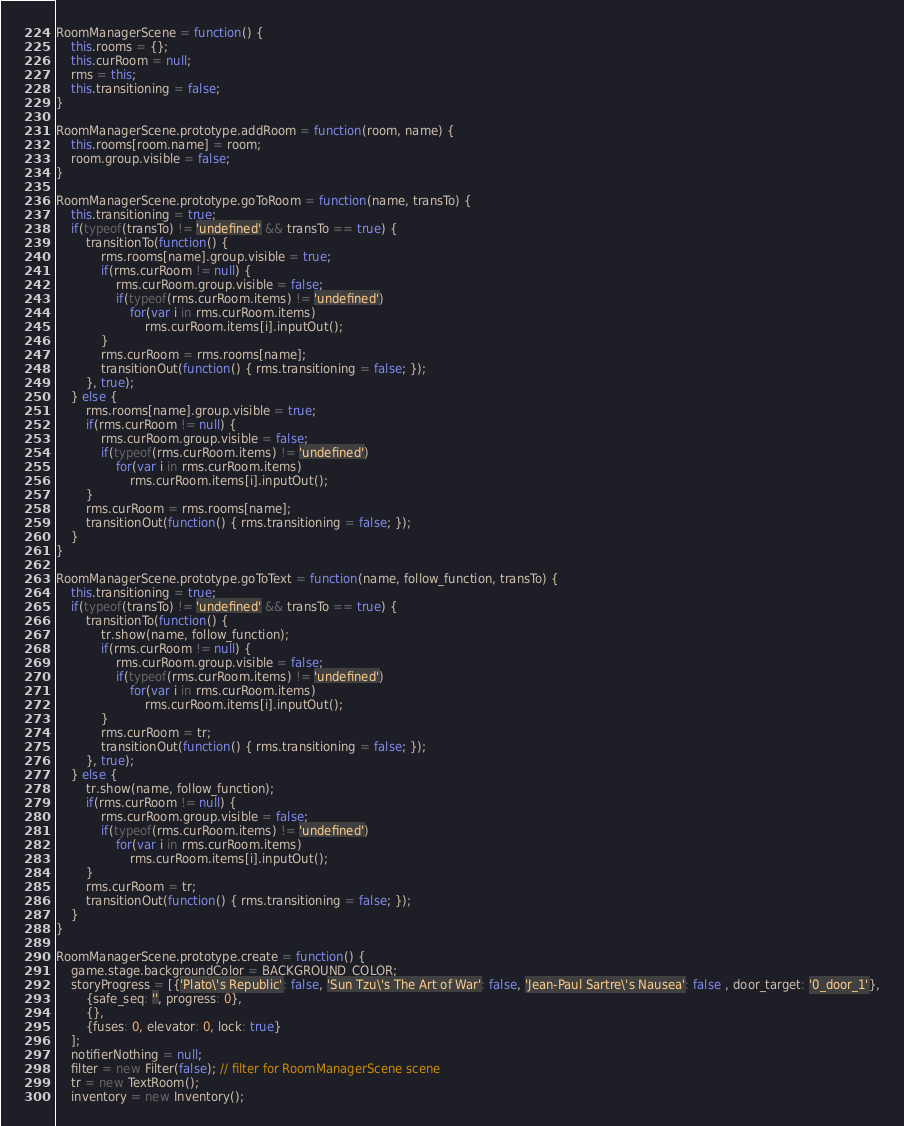<code> <loc_0><loc_0><loc_500><loc_500><_JavaScript_>RoomManagerScene = function() {
	this.rooms = {};
	this.curRoom = null;
	rms = this;
	this.transitioning = false;
}

RoomManagerScene.prototype.addRoom = function(room, name) {
	this.rooms[room.name] = room;
	room.group.visible = false;
}

RoomManagerScene.prototype.goToRoom = function(name, transTo) {
	this.transitioning = true;
	if(typeof(transTo) != 'undefined' && transTo == true) {
		transitionTo(function() {
			rms.rooms[name].group.visible = true;
			if(rms.curRoom != null) {
				rms.curRoom.group.visible = false;
				if(typeof(rms.curRoom.items) != 'undefined')
					for(var i in rms.curRoom.items)
						rms.curRoom.items[i].inputOut();
			}
			rms.curRoom = rms.rooms[name];
			transitionOut(function() { rms.transitioning = false; });
		}, true);
	} else {
		rms.rooms[name].group.visible = true;
		if(rms.curRoom != null) {
			rms.curRoom.group.visible = false;
			if(typeof(rms.curRoom.items) != 'undefined')
				for(var i in rms.curRoom.items)
					rms.curRoom.items[i].inputOut();
		}
		rms.curRoom = rms.rooms[name];
		transitionOut(function() { rms.transitioning = false; });
	}
}

RoomManagerScene.prototype.goToText = function(name, follow_function, transTo) {
	this.transitioning = true;
	if(typeof(transTo) != 'undefined' && transTo == true) {
		transitionTo(function() {
			tr.show(name, follow_function);
			if(rms.curRoom != null) {
				rms.curRoom.group.visible = false;
				if(typeof(rms.curRoom.items) != 'undefined')
					for(var i in rms.curRoom.items)
						rms.curRoom.items[i].inputOut();
			}
			rms.curRoom = tr;
			transitionOut(function() { rms.transitioning = false; });
		}, true);
	} else {
		tr.show(name, follow_function);
		if(rms.curRoom != null) {
			rms.curRoom.group.visible = false;
			if(typeof(rms.curRoom.items) != 'undefined')
				for(var i in rms.curRoom.items)
					rms.curRoom.items[i].inputOut();
		}
		rms.curRoom = tr;
		transitionOut(function() { rms.transitioning = false; });
	}
}

RoomManagerScene.prototype.create = function() {
	game.stage.backgroundColor = BACKGROUND_COLOR;
	storyProgress = [{'Plato\'s Republic': false, 'Sun Tzu\'s The Art of War': false, 'Jean-Paul Sartre\'s Nausea': false , door_target: '0_door_1'},
		{safe_seq: '', progress: 0},
		{},
		{fuses: 0, elevator: 0, lock: true}
	];
	notifierNothing = null;
	filter = new Filter(false); // filter for RoomManagerScene scene
	tr = new TextRoom();
	inventory = new Inventory();</code> 